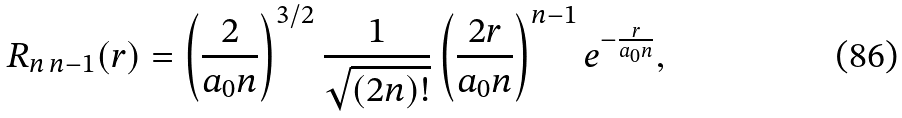Convert formula to latex. <formula><loc_0><loc_0><loc_500><loc_500>R _ { n \, n - 1 } ( r ) = \left ( \frac { 2 } { a _ { 0 } n } \right ) ^ { 3 / 2 } \frac { 1 } { \sqrt { ( 2 n ) ! } } \left ( \frac { 2 r } { a _ { 0 } n } \right ) ^ { n - 1 } e ^ { - \frac { r } { a _ { 0 } n } } ,</formula> 